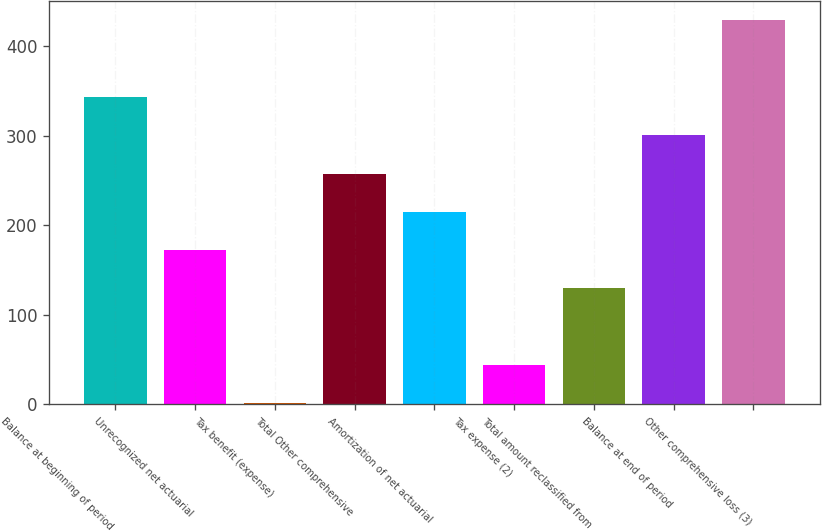<chart> <loc_0><loc_0><loc_500><loc_500><bar_chart><fcel>Balance at beginning of period<fcel>Unrecognized net actuarial<fcel>Tax benefit (expense)<fcel>Total Other comprehensive<fcel>Amortization of net actuarial<fcel>Tax expense (2)<fcel>Total amount reclassified from<fcel>Balance at end of period<fcel>Other comprehensive loss (3)<nl><fcel>343.4<fcel>172.2<fcel>1<fcel>257.8<fcel>215<fcel>43.8<fcel>129.4<fcel>300.6<fcel>429<nl></chart> 